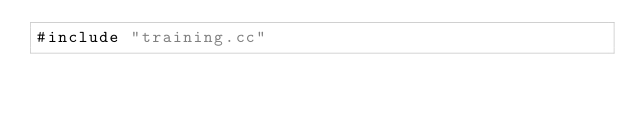Convert code to text. <code><loc_0><loc_0><loc_500><loc_500><_Cuda_>#include "training.cc"
</code> 